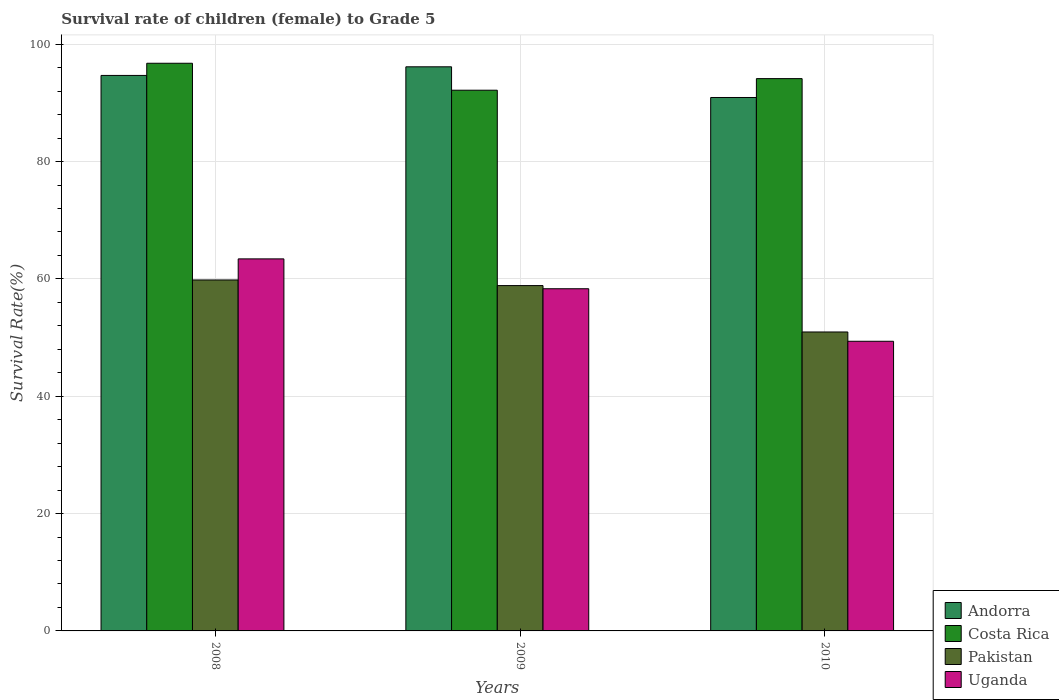How many different coloured bars are there?
Offer a very short reply. 4. How many bars are there on the 1st tick from the right?
Offer a very short reply. 4. What is the survival rate of female children to grade 5 in Andorra in 2010?
Provide a short and direct response. 90.92. Across all years, what is the maximum survival rate of female children to grade 5 in Uganda?
Offer a very short reply. 63.41. Across all years, what is the minimum survival rate of female children to grade 5 in Costa Rica?
Ensure brevity in your answer.  92.16. What is the total survival rate of female children to grade 5 in Pakistan in the graph?
Keep it short and to the point. 169.63. What is the difference between the survival rate of female children to grade 5 in Pakistan in 2008 and that in 2009?
Offer a very short reply. 0.96. What is the difference between the survival rate of female children to grade 5 in Costa Rica in 2008 and the survival rate of female children to grade 5 in Uganda in 2009?
Ensure brevity in your answer.  38.43. What is the average survival rate of female children to grade 5 in Andorra per year?
Your answer should be very brief. 93.92. In the year 2010, what is the difference between the survival rate of female children to grade 5 in Andorra and survival rate of female children to grade 5 in Costa Rica?
Offer a terse response. -3.22. What is the ratio of the survival rate of female children to grade 5 in Costa Rica in 2008 to that in 2010?
Offer a very short reply. 1.03. What is the difference between the highest and the second highest survival rate of female children to grade 5 in Costa Rica?
Keep it short and to the point. 2.62. What is the difference between the highest and the lowest survival rate of female children to grade 5 in Costa Rica?
Your answer should be compact. 4.59. In how many years, is the survival rate of female children to grade 5 in Pakistan greater than the average survival rate of female children to grade 5 in Pakistan taken over all years?
Your answer should be very brief. 2. What does the 3rd bar from the left in 2009 represents?
Keep it short and to the point. Pakistan. What does the 2nd bar from the right in 2008 represents?
Keep it short and to the point. Pakistan. Is it the case that in every year, the sum of the survival rate of female children to grade 5 in Costa Rica and survival rate of female children to grade 5 in Pakistan is greater than the survival rate of female children to grade 5 in Andorra?
Provide a succinct answer. Yes. How many bars are there?
Your answer should be very brief. 12. How many years are there in the graph?
Ensure brevity in your answer.  3. What is the difference between two consecutive major ticks on the Y-axis?
Keep it short and to the point. 20. Does the graph contain any zero values?
Offer a terse response. No. How many legend labels are there?
Ensure brevity in your answer.  4. What is the title of the graph?
Provide a short and direct response. Survival rate of children (female) to Grade 5. Does "Sub-Saharan Africa (all income levels)" appear as one of the legend labels in the graph?
Your answer should be very brief. No. What is the label or title of the X-axis?
Provide a succinct answer. Years. What is the label or title of the Y-axis?
Offer a very short reply. Survival Rate(%). What is the Survival Rate(%) of Andorra in 2008?
Ensure brevity in your answer.  94.68. What is the Survival Rate(%) in Costa Rica in 2008?
Keep it short and to the point. 96.76. What is the Survival Rate(%) in Pakistan in 2008?
Provide a succinct answer. 59.82. What is the Survival Rate(%) of Uganda in 2008?
Ensure brevity in your answer.  63.41. What is the Survival Rate(%) in Andorra in 2009?
Ensure brevity in your answer.  96.15. What is the Survival Rate(%) in Costa Rica in 2009?
Keep it short and to the point. 92.16. What is the Survival Rate(%) of Pakistan in 2009?
Make the answer very short. 58.86. What is the Survival Rate(%) of Uganda in 2009?
Give a very brief answer. 58.32. What is the Survival Rate(%) in Andorra in 2010?
Your response must be concise. 90.92. What is the Survival Rate(%) in Costa Rica in 2010?
Your answer should be compact. 94.14. What is the Survival Rate(%) in Pakistan in 2010?
Give a very brief answer. 50.95. What is the Survival Rate(%) in Uganda in 2010?
Provide a short and direct response. 49.37. Across all years, what is the maximum Survival Rate(%) in Andorra?
Ensure brevity in your answer.  96.15. Across all years, what is the maximum Survival Rate(%) in Costa Rica?
Keep it short and to the point. 96.76. Across all years, what is the maximum Survival Rate(%) in Pakistan?
Your answer should be compact. 59.82. Across all years, what is the maximum Survival Rate(%) in Uganda?
Give a very brief answer. 63.41. Across all years, what is the minimum Survival Rate(%) of Andorra?
Offer a terse response. 90.92. Across all years, what is the minimum Survival Rate(%) of Costa Rica?
Ensure brevity in your answer.  92.16. Across all years, what is the minimum Survival Rate(%) of Pakistan?
Provide a succinct answer. 50.95. Across all years, what is the minimum Survival Rate(%) in Uganda?
Provide a succinct answer. 49.37. What is the total Survival Rate(%) in Andorra in the graph?
Give a very brief answer. 281.76. What is the total Survival Rate(%) of Costa Rica in the graph?
Make the answer very short. 283.06. What is the total Survival Rate(%) in Pakistan in the graph?
Keep it short and to the point. 169.63. What is the total Survival Rate(%) of Uganda in the graph?
Your response must be concise. 171.11. What is the difference between the Survival Rate(%) of Andorra in 2008 and that in 2009?
Your answer should be very brief. -1.47. What is the difference between the Survival Rate(%) in Costa Rica in 2008 and that in 2009?
Keep it short and to the point. 4.59. What is the difference between the Survival Rate(%) of Pakistan in 2008 and that in 2009?
Keep it short and to the point. 0.96. What is the difference between the Survival Rate(%) of Uganda in 2008 and that in 2009?
Provide a short and direct response. 5.09. What is the difference between the Survival Rate(%) in Andorra in 2008 and that in 2010?
Give a very brief answer. 3.76. What is the difference between the Survival Rate(%) of Costa Rica in 2008 and that in 2010?
Give a very brief answer. 2.62. What is the difference between the Survival Rate(%) of Pakistan in 2008 and that in 2010?
Offer a terse response. 8.87. What is the difference between the Survival Rate(%) in Uganda in 2008 and that in 2010?
Make the answer very short. 14.04. What is the difference between the Survival Rate(%) in Andorra in 2009 and that in 2010?
Give a very brief answer. 5.23. What is the difference between the Survival Rate(%) in Costa Rica in 2009 and that in 2010?
Your answer should be compact. -1.98. What is the difference between the Survival Rate(%) of Pakistan in 2009 and that in 2010?
Offer a terse response. 7.91. What is the difference between the Survival Rate(%) in Uganda in 2009 and that in 2010?
Offer a terse response. 8.95. What is the difference between the Survival Rate(%) of Andorra in 2008 and the Survival Rate(%) of Costa Rica in 2009?
Keep it short and to the point. 2.52. What is the difference between the Survival Rate(%) of Andorra in 2008 and the Survival Rate(%) of Pakistan in 2009?
Provide a succinct answer. 35.82. What is the difference between the Survival Rate(%) of Andorra in 2008 and the Survival Rate(%) of Uganda in 2009?
Your answer should be very brief. 36.36. What is the difference between the Survival Rate(%) of Costa Rica in 2008 and the Survival Rate(%) of Pakistan in 2009?
Give a very brief answer. 37.9. What is the difference between the Survival Rate(%) of Costa Rica in 2008 and the Survival Rate(%) of Uganda in 2009?
Your answer should be compact. 38.43. What is the difference between the Survival Rate(%) in Pakistan in 2008 and the Survival Rate(%) in Uganda in 2009?
Give a very brief answer. 1.5. What is the difference between the Survival Rate(%) in Andorra in 2008 and the Survival Rate(%) in Costa Rica in 2010?
Provide a succinct answer. 0.54. What is the difference between the Survival Rate(%) in Andorra in 2008 and the Survival Rate(%) in Pakistan in 2010?
Give a very brief answer. 43.73. What is the difference between the Survival Rate(%) in Andorra in 2008 and the Survival Rate(%) in Uganda in 2010?
Your response must be concise. 45.31. What is the difference between the Survival Rate(%) in Costa Rica in 2008 and the Survival Rate(%) in Pakistan in 2010?
Provide a succinct answer. 45.8. What is the difference between the Survival Rate(%) in Costa Rica in 2008 and the Survival Rate(%) in Uganda in 2010?
Your answer should be compact. 47.39. What is the difference between the Survival Rate(%) in Pakistan in 2008 and the Survival Rate(%) in Uganda in 2010?
Ensure brevity in your answer.  10.45. What is the difference between the Survival Rate(%) of Andorra in 2009 and the Survival Rate(%) of Costa Rica in 2010?
Your response must be concise. 2.01. What is the difference between the Survival Rate(%) in Andorra in 2009 and the Survival Rate(%) in Pakistan in 2010?
Your answer should be compact. 45.2. What is the difference between the Survival Rate(%) in Andorra in 2009 and the Survival Rate(%) in Uganda in 2010?
Make the answer very short. 46.78. What is the difference between the Survival Rate(%) of Costa Rica in 2009 and the Survival Rate(%) of Pakistan in 2010?
Offer a very short reply. 41.21. What is the difference between the Survival Rate(%) of Costa Rica in 2009 and the Survival Rate(%) of Uganda in 2010?
Provide a short and direct response. 42.79. What is the difference between the Survival Rate(%) of Pakistan in 2009 and the Survival Rate(%) of Uganda in 2010?
Make the answer very short. 9.49. What is the average Survival Rate(%) of Andorra per year?
Provide a short and direct response. 93.92. What is the average Survival Rate(%) in Costa Rica per year?
Offer a terse response. 94.35. What is the average Survival Rate(%) of Pakistan per year?
Offer a terse response. 56.55. What is the average Survival Rate(%) in Uganda per year?
Ensure brevity in your answer.  57.04. In the year 2008, what is the difference between the Survival Rate(%) of Andorra and Survival Rate(%) of Costa Rica?
Make the answer very short. -2.08. In the year 2008, what is the difference between the Survival Rate(%) of Andorra and Survival Rate(%) of Pakistan?
Your answer should be very brief. 34.86. In the year 2008, what is the difference between the Survival Rate(%) of Andorra and Survival Rate(%) of Uganda?
Give a very brief answer. 31.27. In the year 2008, what is the difference between the Survival Rate(%) of Costa Rica and Survival Rate(%) of Pakistan?
Offer a very short reply. 36.94. In the year 2008, what is the difference between the Survival Rate(%) in Costa Rica and Survival Rate(%) in Uganda?
Offer a very short reply. 33.34. In the year 2008, what is the difference between the Survival Rate(%) in Pakistan and Survival Rate(%) in Uganda?
Ensure brevity in your answer.  -3.59. In the year 2009, what is the difference between the Survival Rate(%) in Andorra and Survival Rate(%) in Costa Rica?
Your response must be concise. 3.99. In the year 2009, what is the difference between the Survival Rate(%) of Andorra and Survival Rate(%) of Pakistan?
Provide a succinct answer. 37.29. In the year 2009, what is the difference between the Survival Rate(%) in Andorra and Survival Rate(%) in Uganda?
Ensure brevity in your answer.  37.83. In the year 2009, what is the difference between the Survival Rate(%) in Costa Rica and Survival Rate(%) in Pakistan?
Your response must be concise. 33.3. In the year 2009, what is the difference between the Survival Rate(%) of Costa Rica and Survival Rate(%) of Uganda?
Offer a terse response. 33.84. In the year 2009, what is the difference between the Survival Rate(%) of Pakistan and Survival Rate(%) of Uganda?
Your answer should be compact. 0.54. In the year 2010, what is the difference between the Survival Rate(%) in Andorra and Survival Rate(%) in Costa Rica?
Offer a terse response. -3.22. In the year 2010, what is the difference between the Survival Rate(%) in Andorra and Survival Rate(%) in Pakistan?
Keep it short and to the point. 39.97. In the year 2010, what is the difference between the Survival Rate(%) in Andorra and Survival Rate(%) in Uganda?
Ensure brevity in your answer.  41.55. In the year 2010, what is the difference between the Survival Rate(%) in Costa Rica and Survival Rate(%) in Pakistan?
Offer a terse response. 43.19. In the year 2010, what is the difference between the Survival Rate(%) of Costa Rica and Survival Rate(%) of Uganda?
Provide a short and direct response. 44.77. In the year 2010, what is the difference between the Survival Rate(%) of Pakistan and Survival Rate(%) of Uganda?
Ensure brevity in your answer.  1.58. What is the ratio of the Survival Rate(%) in Andorra in 2008 to that in 2009?
Your answer should be very brief. 0.98. What is the ratio of the Survival Rate(%) of Costa Rica in 2008 to that in 2009?
Give a very brief answer. 1.05. What is the ratio of the Survival Rate(%) of Pakistan in 2008 to that in 2009?
Provide a succinct answer. 1.02. What is the ratio of the Survival Rate(%) in Uganda in 2008 to that in 2009?
Provide a succinct answer. 1.09. What is the ratio of the Survival Rate(%) in Andorra in 2008 to that in 2010?
Offer a terse response. 1.04. What is the ratio of the Survival Rate(%) of Costa Rica in 2008 to that in 2010?
Ensure brevity in your answer.  1.03. What is the ratio of the Survival Rate(%) in Pakistan in 2008 to that in 2010?
Provide a short and direct response. 1.17. What is the ratio of the Survival Rate(%) in Uganda in 2008 to that in 2010?
Offer a terse response. 1.28. What is the ratio of the Survival Rate(%) of Andorra in 2009 to that in 2010?
Your answer should be compact. 1.06. What is the ratio of the Survival Rate(%) in Costa Rica in 2009 to that in 2010?
Your answer should be very brief. 0.98. What is the ratio of the Survival Rate(%) of Pakistan in 2009 to that in 2010?
Give a very brief answer. 1.16. What is the ratio of the Survival Rate(%) of Uganda in 2009 to that in 2010?
Offer a terse response. 1.18. What is the difference between the highest and the second highest Survival Rate(%) of Andorra?
Offer a very short reply. 1.47. What is the difference between the highest and the second highest Survival Rate(%) in Costa Rica?
Keep it short and to the point. 2.62. What is the difference between the highest and the second highest Survival Rate(%) in Pakistan?
Give a very brief answer. 0.96. What is the difference between the highest and the second highest Survival Rate(%) of Uganda?
Offer a terse response. 5.09. What is the difference between the highest and the lowest Survival Rate(%) of Andorra?
Offer a very short reply. 5.23. What is the difference between the highest and the lowest Survival Rate(%) of Costa Rica?
Ensure brevity in your answer.  4.59. What is the difference between the highest and the lowest Survival Rate(%) of Pakistan?
Your response must be concise. 8.87. What is the difference between the highest and the lowest Survival Rate(%) of Uganda?
Give a very brief answer. 14.04. 